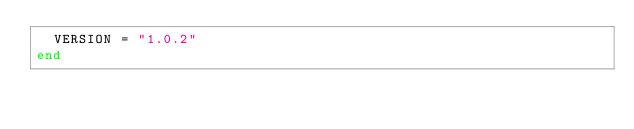Convert code to text. <code><loc_0><loc_0><loc_500><loc_500><_Ruby_>  VERSION = "1.0.2"
end

</code> 